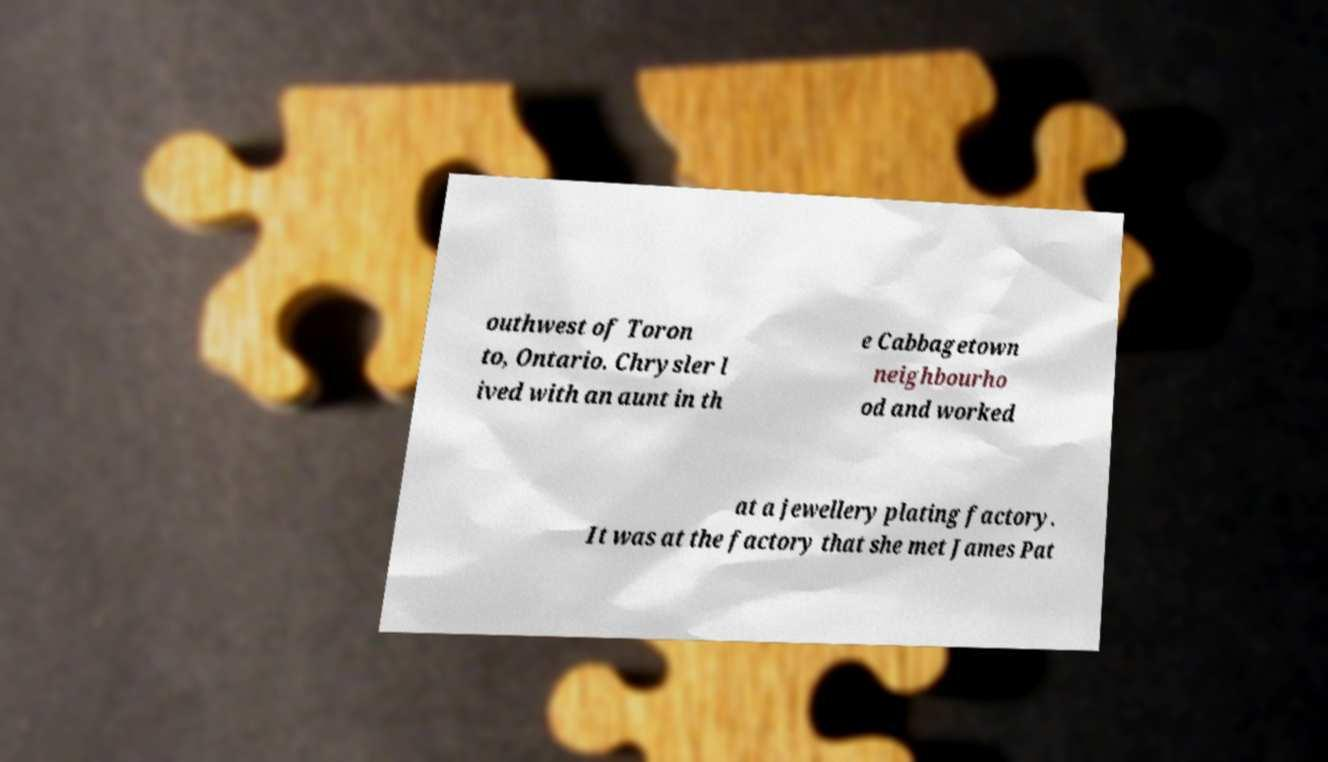I need the written content from this picture converted into text. Can you do that? outhwest of Toron to, Ontario. Chrysler l ived with an aunt in th e Cabbagetown neighbourho od and worked at a jewellery plating factory. It was at the factory that she met James Pat 